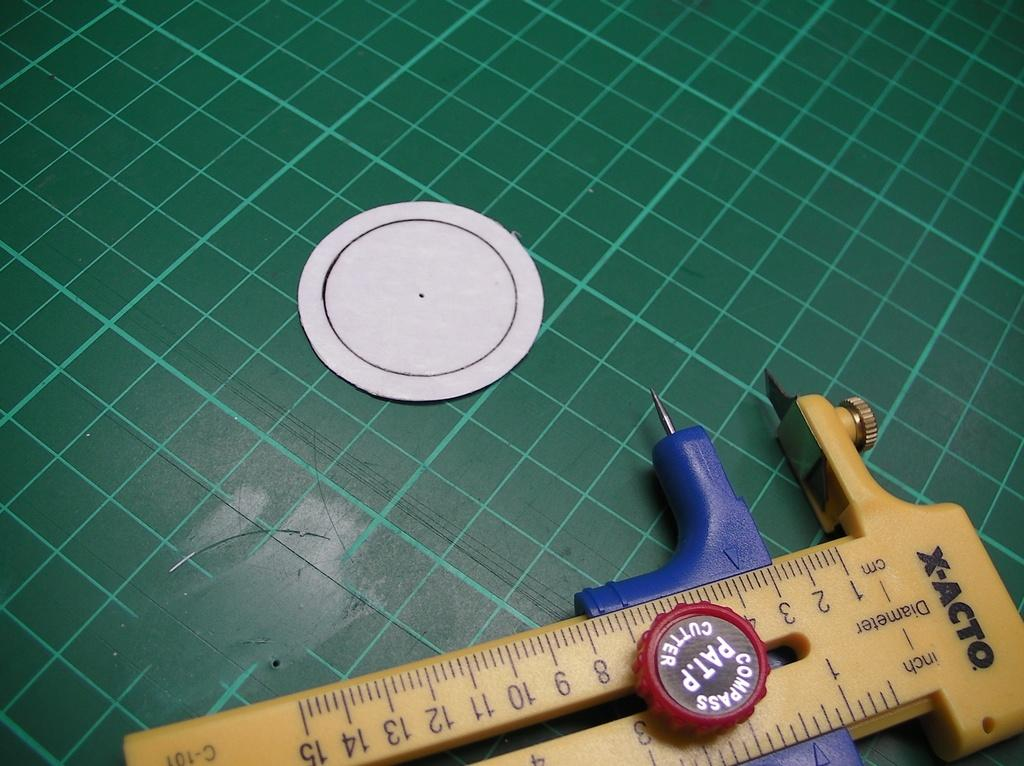<image>
Write a terse but informative summary of the picture. An X-Acto measuring device is laying on a green surface. 